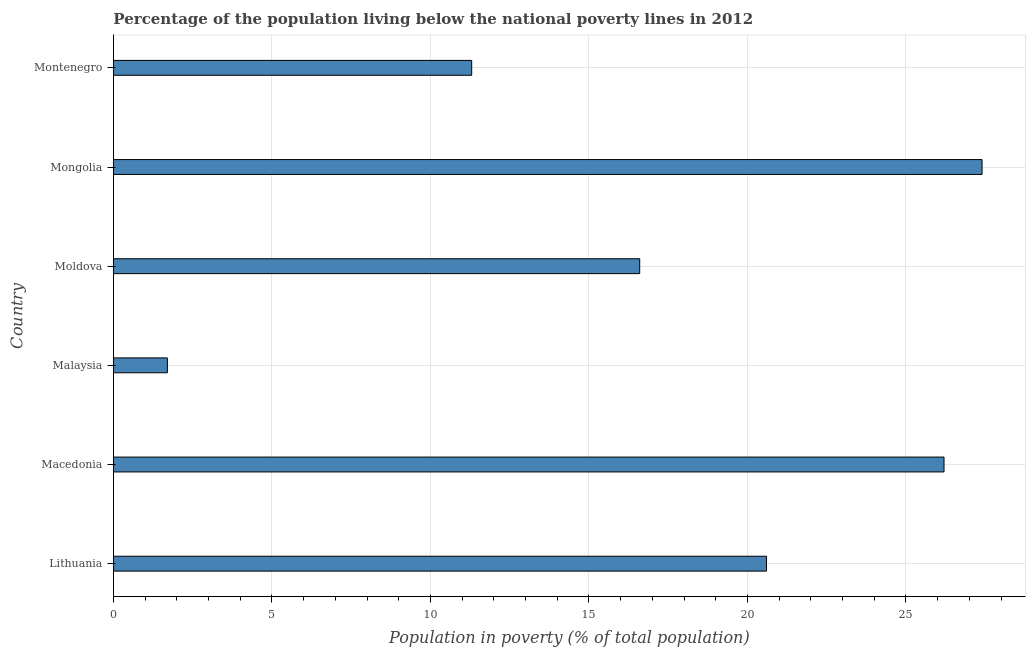Does the graph contain grids?
Give a very brief answer. Yes. What is the title of the graph?
Offer a very short reply. Percentage of the population living below the national poverty lines in 2012. What is the label or title of the X-axis?
Your response must be concise. Population in poverty (% of total population). What is the percentage of population living below poverty line in Montenegro?
Make the answer very short. 11.3. Across all countries, what is the maximum percentage of population living below poverty line?
Give a very brief answer. 27.4. In which country was the percentage of population living below poverty line maximum?
Your answer should be compact. Mongolia. In which country was the percentage of population living below poverty line minimum?
Your response must be concise. Malaysia. What is the sum of the percentage of population living below poverty line?
Offer a very short reply. 103.8. What is the average percentage of population living below poverty line per country?
Your response must be concise. 17.3. What is the median percentage of population living below poverty line?
Keep it short and to the point. 18.6. What is the ratio of the percentage of population living below poverty line in Lithuania to that in Macedonia?
Your response must be concise. 0.79. Is the sum of the percentage of population living below poverty line in Moldova and Montenegro greater than the maximum percentage of population living below poverty line across all countries?
Your answer should be compact. Yes. What is the difference between the highest and the lowest percentage of population living below poverty line?
Your answer should be very brief. 25.7. In how many countries, is the percentage of population living below poverty line greater than the average percentage of population living below poverty line taken over all countries?
Your response must be concise. 3. How many bars are there?
Your answer should be compact. 6. Are all the bars in the graph horizontal?
Your answer should be compact. Yes. How many countries are there in the graph?
Give a very brief answer. 6. What is the Population in poverty (% of total population) of Lithuania?
Keep it short and to the point. 20.6. What is the Population in poverty (% of total population) of Macedonia?
Provide a succinct answer. 26.2. What is the Population in poverty (% of total population) in Moldova?
Provide a succinct answer. 16.6. What is the Population in poverty (% of total population) of Mongolia?
Offer a very short reply. 27.4. What is the Population in poverty (% of total population) of Montenegro?
Make the answer very short. 11.3. What is the difference between the Population in poverty (% of total population) in Lithuania and Macedonia?
Provide a short and direct response. -5.6. What is the difference between the Population in poverty (% of total population) in Lithuania and Malaysia?
Your response must be concise. 18.9. What is the difference between the Population in poverty (% of total population) in Lithuania and Mongolia?
Keep it short and to the point. -6.8. What is the difference between the Population in poverty (% of total population) in Lithuania and Montenegro?
Offer a very short reply. 9.3. What is the difference between the Population in poverty (% of total population) in Macedonia and Moldova?
Your response must be concise. 9.6. What is the difference between the Population in poverty (% of total population) in Malaysia and Moldova?
Provide a succinct answer. -14.9. What is the difference between the Population in poverty (% of total population) in Malaysia and Mongolia?
Provide a succinct answer. -25.7. What is the difference between the Population in poverty (% of total population) in Malaysia and Montenegro?
Keep it short and to the point. -9.6. What is the difference between the Population in poverty (% of total population) in Mongolia and Montenegro?
Provide a short and direct response. 16.1. What is the ratio of the Population in poverty (% of total population) in Lithuania to that in Macedonia?
Your answer should be compact. 0.79. What is the ratio of the Population in poverty (% of total population) in Lithuania to that in Malaysia?
Give a very brief answer. 12.12. What is the ratio of the Population in poverty (% of total population) in Lithuania to that in Moldova?
Provide a succinct answer. 1.24. What is the ratio of the Population in poverty (% of total population) in Lithuania to that in Mongolia?
Provide a succinct answer. 0.75. What is the ratio of the Population in poverty (% of total population) in Lithuania to that in Montenegro?
Ensure brevity in your answer.  1.82. What is the ratio of the Population in poverty (% of total population) in Macedonia to that in Malaysia?
Your response must be concise. 15.41. What is the ratio of the Population in poverty (% of total population) in Macedonia to that in Moldova?
Provide a short and direct response. 1.58. What is the ratio of the Population in poverty (% of total population) in Macedonia to that in Mongolia?
Offer a very short reply. 0.96. What is the ratio of the Population in poverty (% of total population) in Macedonia to that in Montenegro?
Make the answer very short. 2.32. What is the ratio of the Population in poverty (% of total population) in Malaysia to that in Moldova?
Offer a very short reply. 0.1. What is the ratio of the Population in poverty (% of total population) in Malaysia to that in Mongolia?
Your answer should be very brief. 0.06. What is the ratio of the Population in poverty (% of total population) in Moldova to that in Mongolia?
Your answer should be compact. 0.61. What is the ratio of the Population in poverty (% of total population) in Moldova to that in Montenegro?
Ensure brevity in your answer.  1.47. What is the ratio of the Population in poverty (% of total population) in Mongolia to that in Montenegro?
Your answer should be compact. 2.42. 